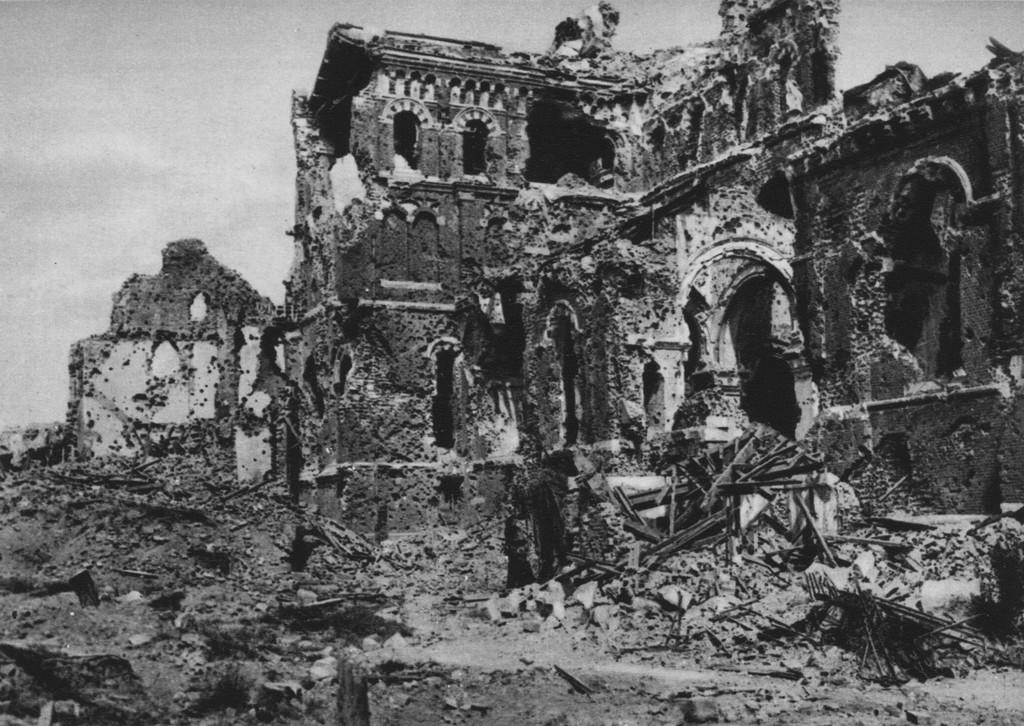What is the color scheme of the image? The image is black and white. What type of structure can be seen in the image? There is an ancient monument in the image. What part of the natural environment is visible in the image? The sky is visible at the top of the image. What degree of difficulty is required to climb the story in the image? There is no story present in the image, as it features an ancient monument and a black and white color scheme. 